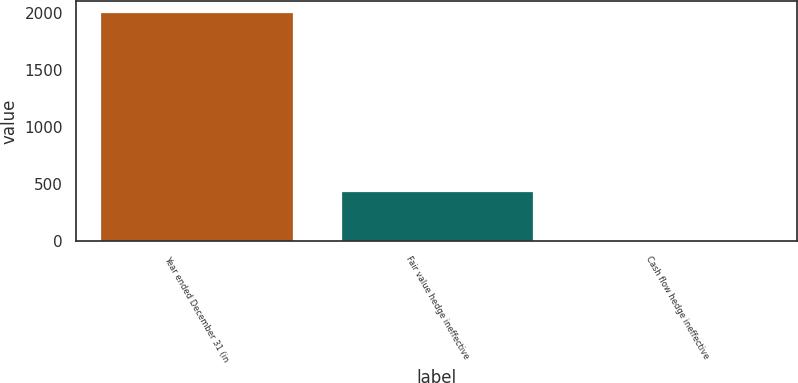Convert chart to OTSL. <chart><loc_0><loc_0><loc_500><loc_500><bar_chart><fcel>Year ended December 31 (in<fcel>Fair value hedge ineffective<fcel>Cash flow hedge ineffective<nl><fcel>2002<fcel>441<fcel>1<nl></chart> 